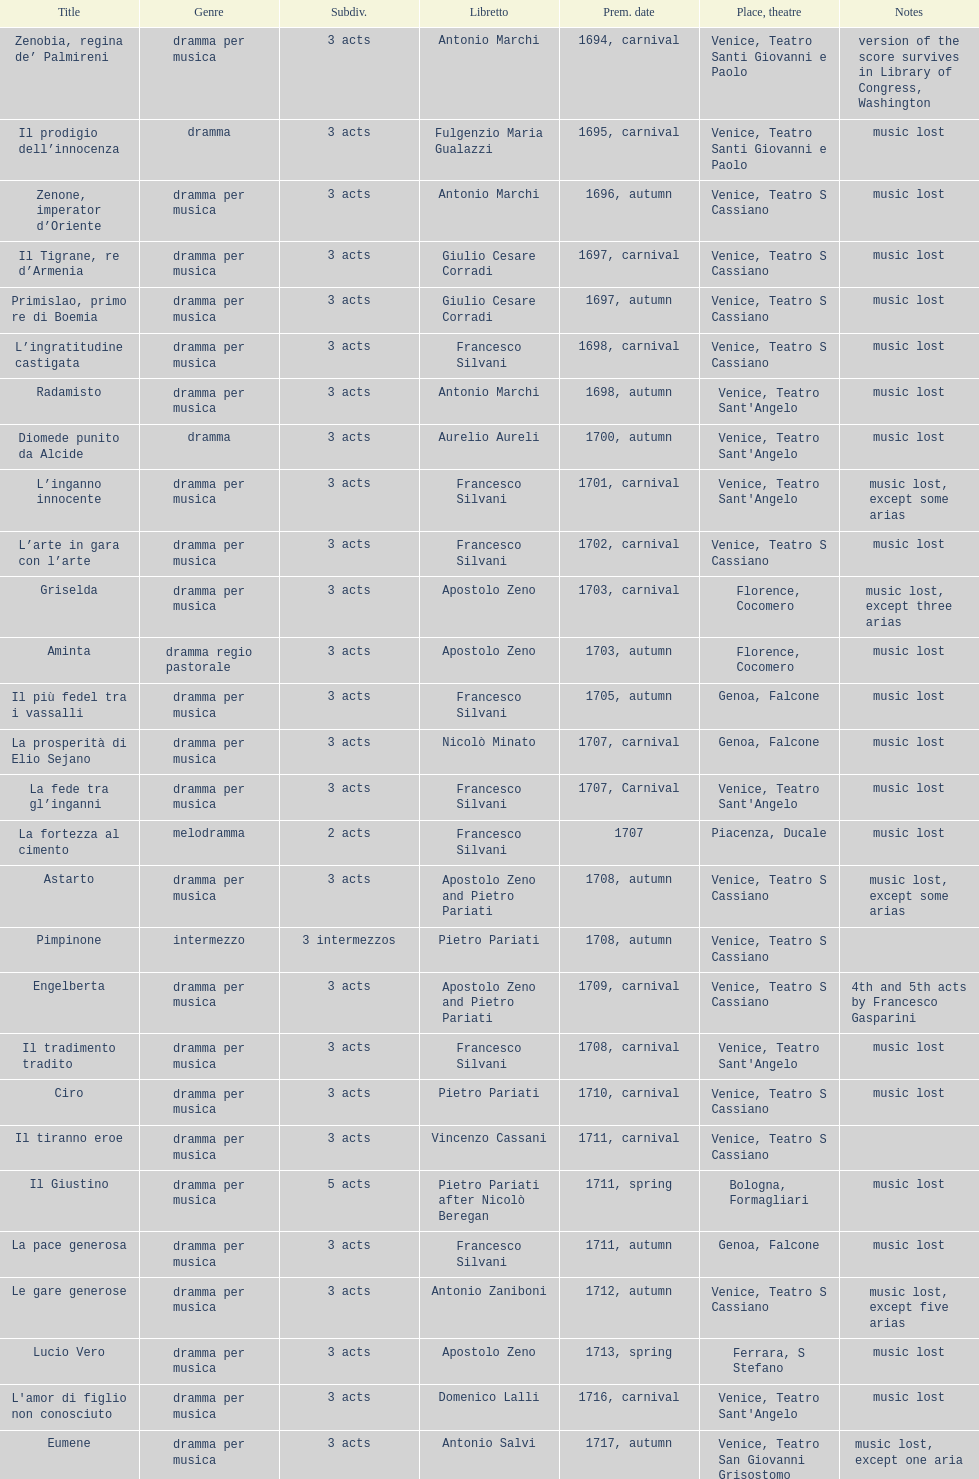Which title premiered directly after candalide? Artamene. 